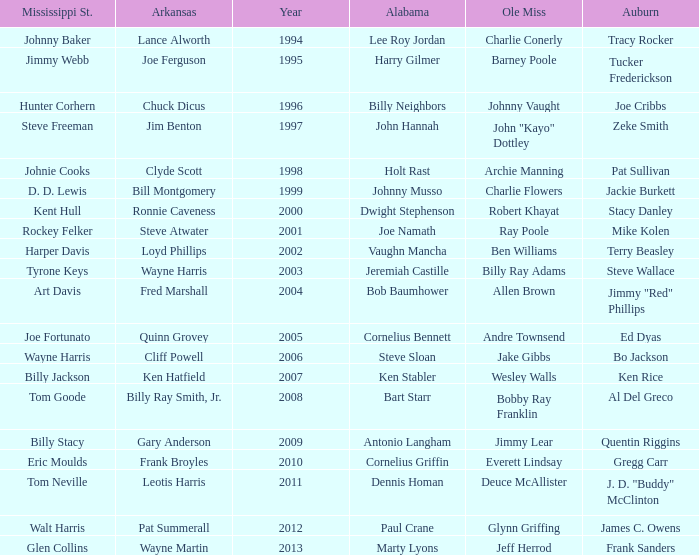Who was the Ole Miss player associated with Chuck Dicus? Johnny Vaught. 